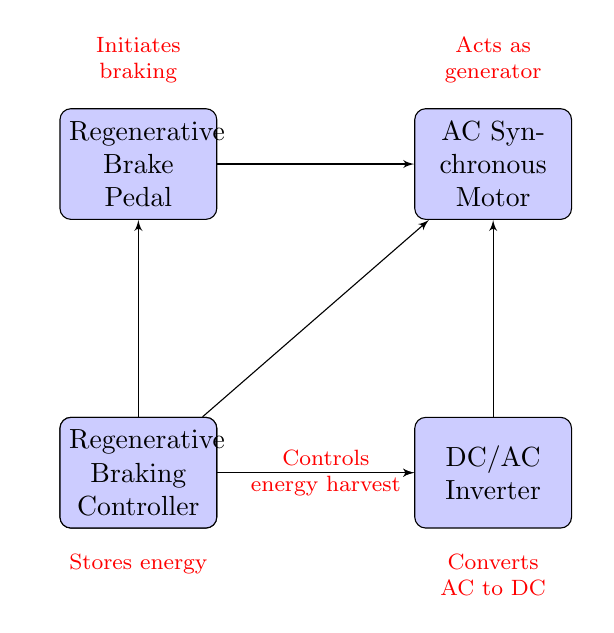What component stores energy in the system? The diagram indicates that the Lithium-Ion Battery is responsible for storing energy in the regenerative braking system. The label below this component states "Stores energy," confirming its role.
Answer: Lithium-Ion Battery How many components are there in total? By counting the number of blocks in the diagram, we see there are five components: Lithium-Ion Battery, DC/AC Inverter, AC Synchronous Motor, Regenerative Brake Pedal, and Regenerative Braking Controller.
Answer: Five What does the DC/AC Inverter do? The diagram specifies that the DC/AC Inverter "Converts AC to DC." This function is directly shown through the label below the inverter block.
Answer: Converts AC to DC Which component initiates braking? The Regenerative Brake Pedal is indicated in the diagram as the component that "Initiates braking," according to the label above the brake block.
Answer: Regenerative Brake Pedal How does the AC Synchronous Motor operate in the system? The diagram illustrates that the AC Synchronous Motor "Acts as generator," which means it converts mechanical energy into electrical energy during braking, as indicated in its label above the block.
Answer: Acts as generator Which component receives control signals from the Regenerative Braking Controller? The diagram shows three arrows pointing from the Regenerative Braking Controller to the Regenerative Brake Pedal, AC Synchronous Motor, and DC/AC Inverter, indicating that it controls these components. Therefore, all of these components receive signals.
Answer: Regenerative Brake Pedal, AC Synchronous Motor, DC/AC Inverter What is the main role of the Regenerative Braking Controller? The diagram explicitly states that its role is to "Controls energy harvest," meaning it manages how energy is captured during braking and sent to the battery. This is reflected in the label to the right of the controller block.
Answer: Controls energy harvest What direction does energy flow from the Lithium-Ion Battery? The diagram indicates that energy flows from the Lithium-Ion Battery to the DC/AC Inverter, as represented by the arrow connecting these two components. This flow demonstrates that the stored energy is being converted for use.
Answer: To the DC/AC Inverter How many control connections does the Regenerative Braking Controller have? The diagram shows three lines coming out of the Regenerative Braking Controller, connecting it to the Regenerative Brake Pedal, AC Synchronous Motor, and DC/AC Inverter. This indicates it has three control connections.
Answer: Three 